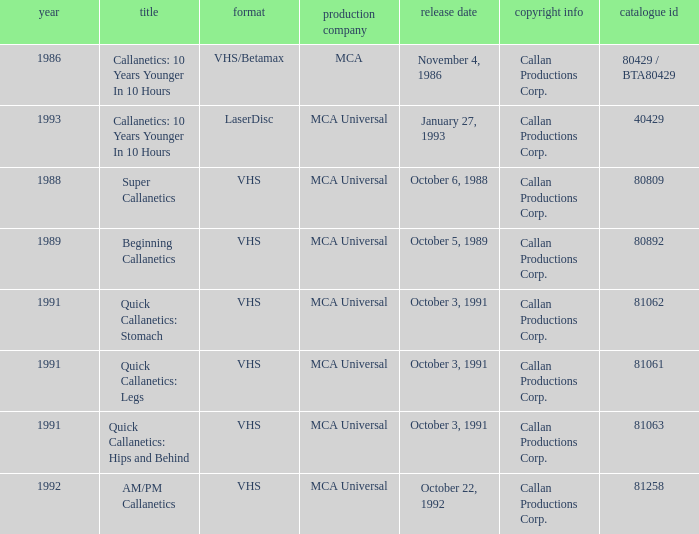Name the studio for super callanetics MCA Universal. 